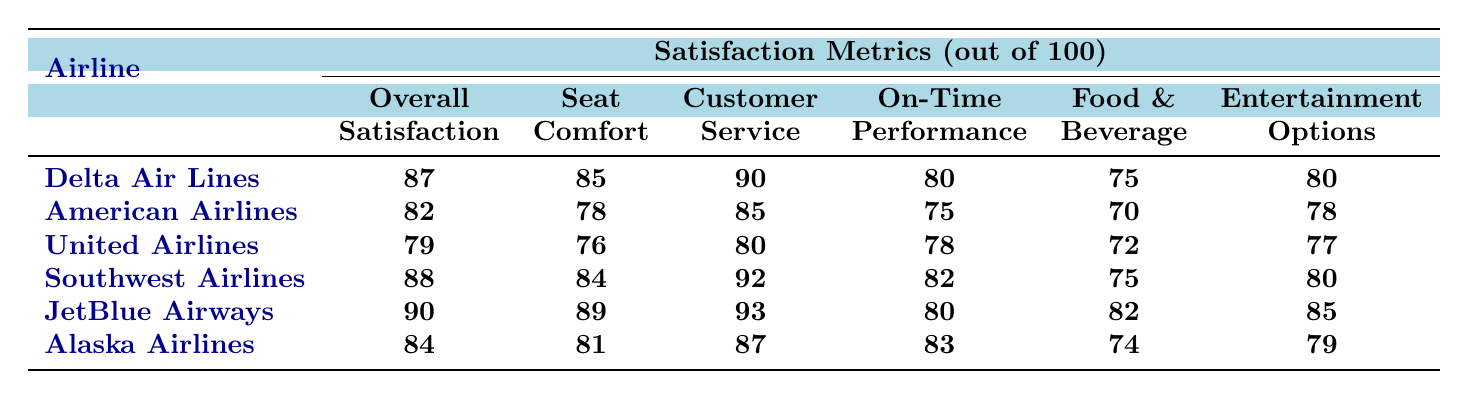What is the overall satisfaction rating for JetBlue Airways? JetBlue Airways has an overall satisfaction rating of 90, as indicated in the table under the Overall Satisfaction column.
Answer: 90 Which airline has the highest customer service score? Looking at the Customer Service scores, JetBlue Airways has the highest score of 93, compared to the other airlines listed.
Answer: JetBlue Airways What is the average seat comfort score for the airlines listed? To calculate the average seat comfort score, sum all the seat comfort values: (85 + 78 + 76 + 84 + 89 + 81) = 493, then divide by the number of airlines, which is 6: 493/6 = approximately 82.17.
Answer: 82.17 Does Southwest Airlines have a higher food and beverage score than American Airlines? Southwest Airlines has a Food & Beverage score of 75, while American Airlines has a score of 70. Since 75 is greater than 70, the answer is yes.
Answer: Yes What is the difference in overall satisfaction between Delta Air Lines and Alaska Airlines? Delta Air Lines has an overall satisfaction of 87 while Alaska Airlines has 84. The difference is calculated as 87 - 84 = 3.
Answer: 3 Which airline scored the lowest in on-time performance? United Airlines scores 78 in on-time performance, which is the lowest compared to the other airlines.
Answer: United Airlines If you combine the entertainment options scores for Southwest Airlines and American Airlines, what would be the total? Southwest Airlines has an entertainment score of 80 and American Airlines has 78. Adding these scores together gives 80 + 78 = 158.
Answer: 158 Which airline has the lowest seat comfort score? American Airlines has the lowest seat comfort score at 78 compared to the other airlines' scores listed.
Answer: American Airlines Is the overall satisfaction score for Alaska Airlines above 80? Alaska Airlines has an overall satisfaction score of 84, which is above 80. Therefore, the answer is yes.
Answer: Yes Which airline has the best food and beverage score among the listed airlines? JetBlue Airways has the highest food and beverage score of 82, which is the highest in the table when compared to others.
Answer: JetBlue Airways 